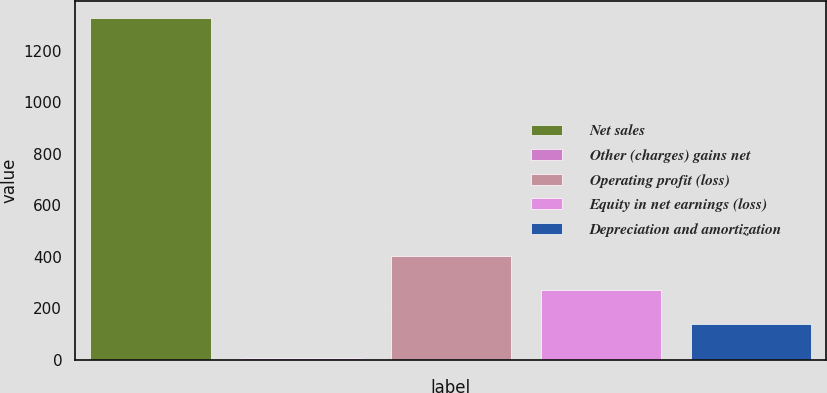Convert chart to OTSL. <chart><loc_0><loc_0><loc_500><loc_500><bar_chart><fcel>Net sales<fcel>Other (charges) gains net<fcel>Operating profit (loss)<fcel>Equity in net earnings (loss)<fcel>Depreciation and amortization<nl><fcel>1326<fcel>7<fcel>402.7<fcel>270.8<fcel>138.9<nl></chart> 